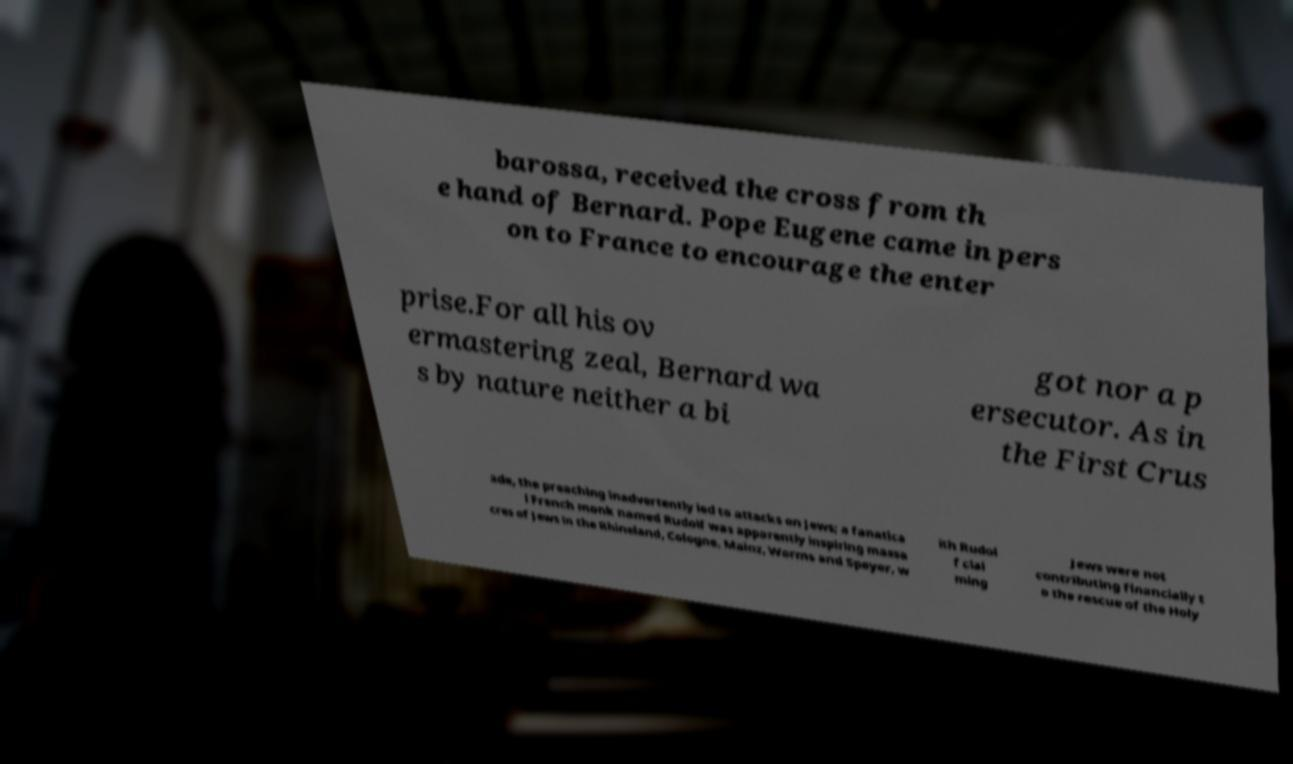Can you read and provide the text displayed in the image?This photo seems to have some interesting text. Can you extract and type it out for me? barossa, received the cross from th e hand of Bernard. Pope Eugene came in pers on to France to encourage the enter prise.For all his ov ermastering zeal, Bernard wa s by nature neither a bi got nor a p ersecutor. As in the First Crus ade, the preaching inadvertently led to attacks on Jews; a fanatica l French monk named Rudolf was apparently inspiring massa cres of Jews in the Rhineland, Cologne, Mainz, Worms and Speyer, w ith Rudol f clai ming Jews were not contributing financially t o the rescue of the Holy 